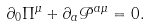<formula> <loc_0><loc_0><loc_500><loc_500>\partial _ { 0 } \Pi ^ { \mu } + \partial _ { a } { \mathcal { P } } ^ { a \mu } = 0 .</formula> 